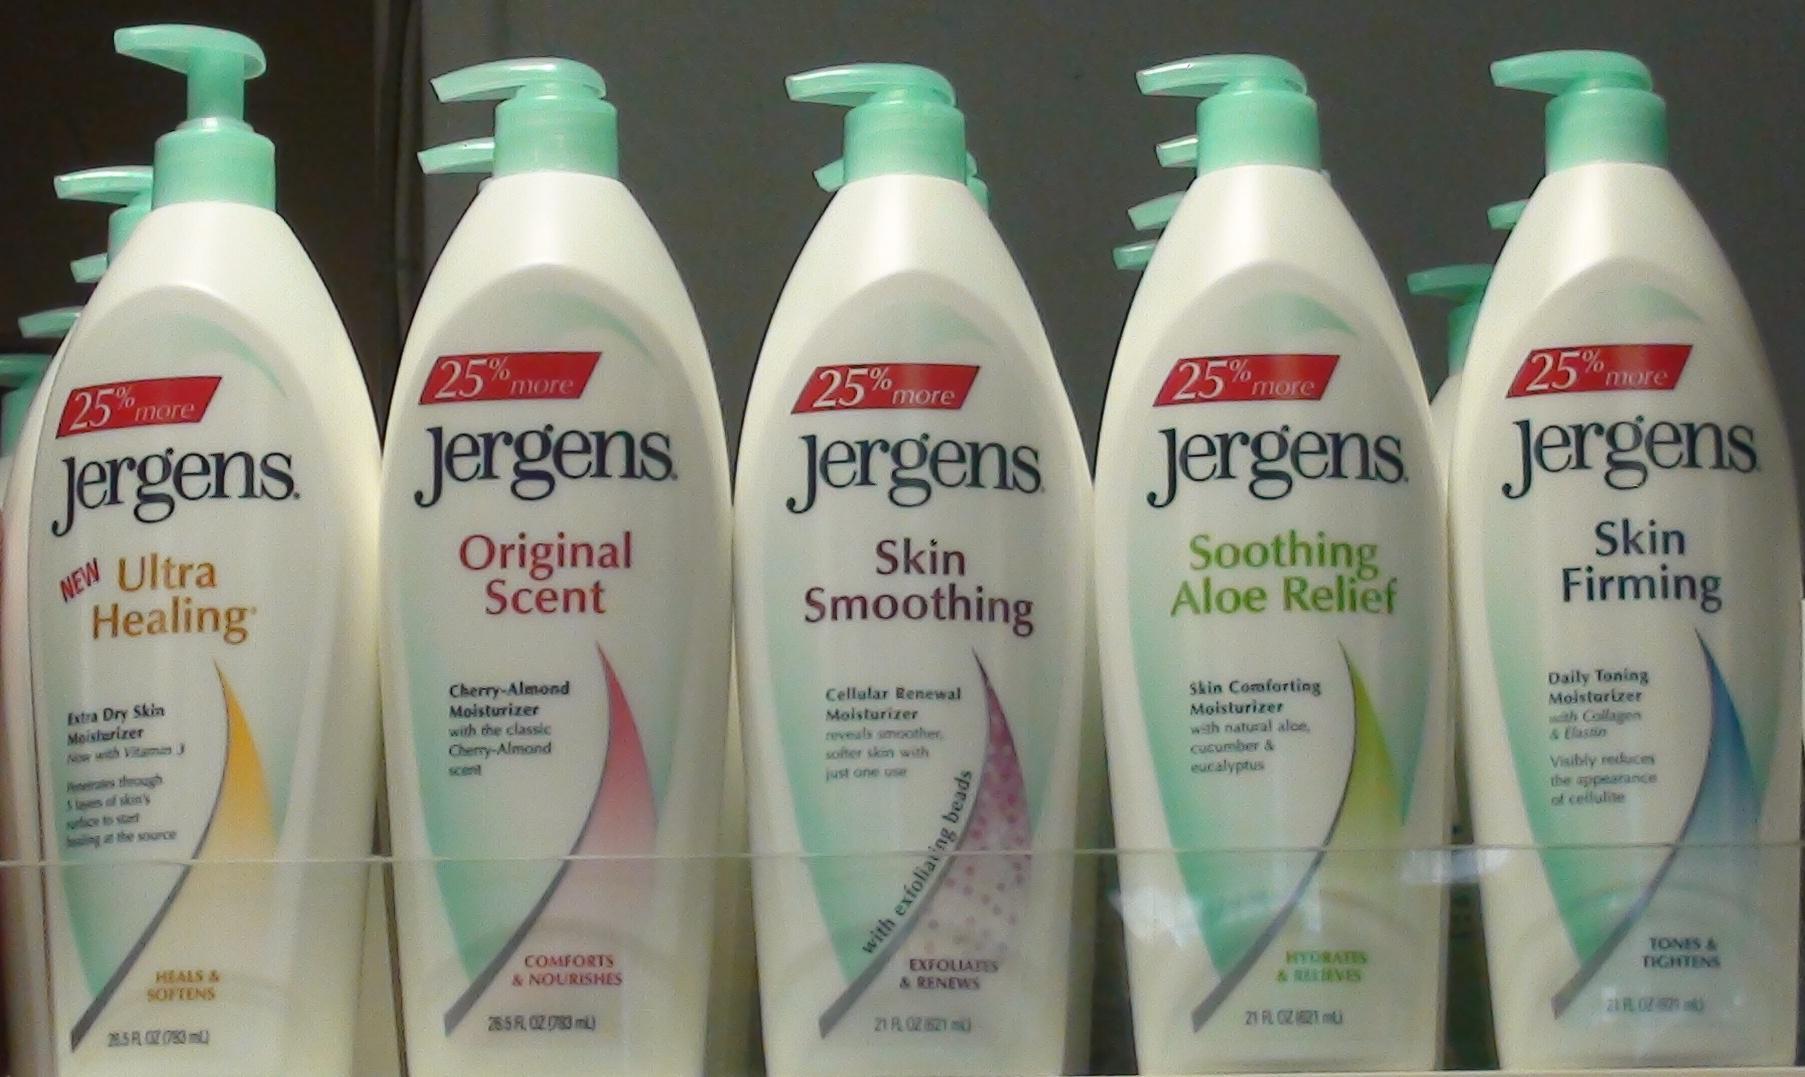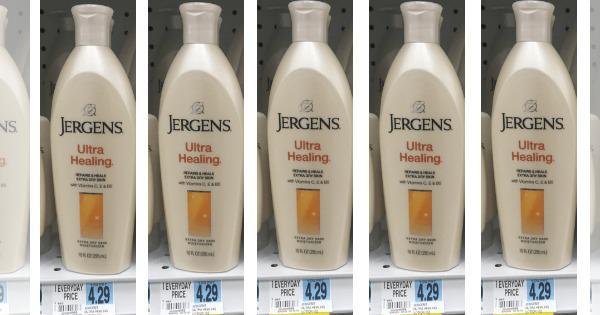The first image is the image on the left, the second image is the image on the right. For the images displayed, is the sentence "No more than three lotion bottles are visible in the left image." factually correct? Answer yes or no. No. 